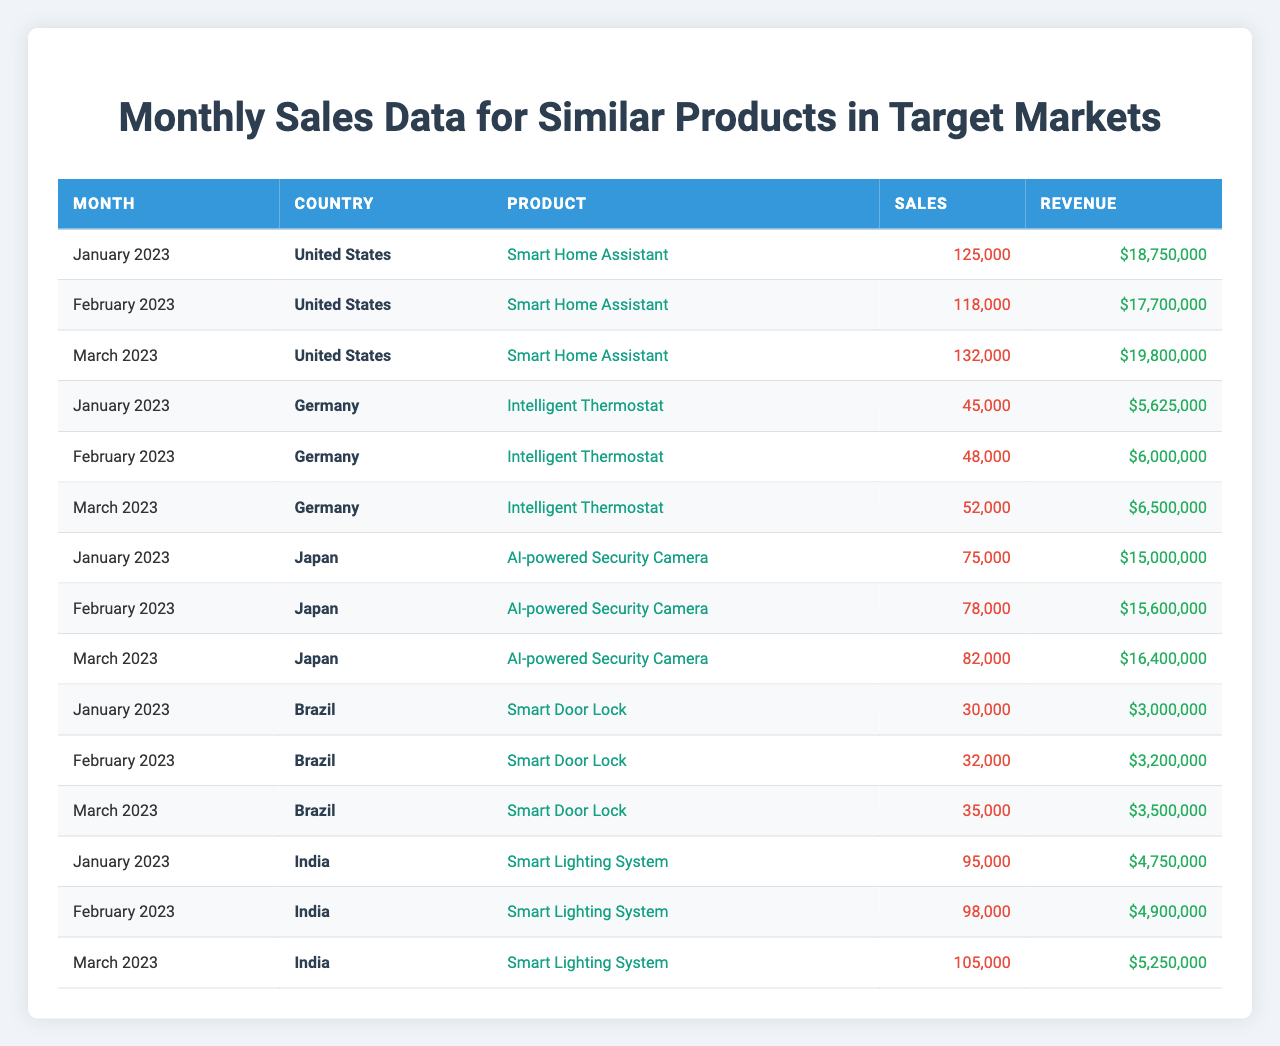What were the total sales for the Smart Home Assistant in the United States in January 2023? The sales figure for the Smart Home Assistant in the United States for January 2023 is listed as 125,000.
Answer: 125,000 Which product had the highest revenue in Japan in February 2023? The table shows that the AI-powered Security Camera had a revenue of $15,600,000 in February 2023, which is higher than any other product listed for Japan.
Answer: AI-powered Security Camera How many sales did the Intelligent Thermostat achieve in Germany in March 2023 compared to February 2023? In March 2023, the Intelligent Thermostat had 52,000 sales while in February 2023, it had 48,000 sales. The difference in sales is 52,000 - 48,000 = 4,000.
Answer: 4,000 What was the total revenue generated by the Smart Lighting System in India during the first quarter of 2023? The revenues for the Smart Lighting System for the first three months are: January $4,750,000, February $4,900,000, and March $5,250,000. Adding these together gives us $4,750,000 + $4,900,000 + $5,250,000 = $14,900,000.
Answer: $14,900,000 Did Brazil's Smart Door Lock experience growth in sales from January to March 2023? The sales figures show that in January it was 30,000, February 32,000, and March 35,000. Since 30,000 < 32,000 < 35,000, we can confirm there was growth.
Answer: Yes What is the average revenue for the Smart Home Assistant in the United States over the first quarter of 2023? The revenues for January, February, and March are $18,750,000, $17,700,000, and $19,800,000 respectively. The total revenue is $18,750,000 + $17,700,000 + $19,800,000 = $56,250,000, and the average is $56,250,000 / 3 = $18,750,000.
Answer: $18,750,000 In which month did India’s Smart Lighting System record the most sales? In India, sales for the Smart Lighting System were 95,000 in January, 98,000 in February, and 105,000 in March. The highest sales figure is 105,000 in March.
Answer: March 2023 What was the percentage increase in sales of the Intelligent Thermostat from February to March 2023 in Germany? The sales for February were 48,000 and for March, 52,000. The increase is 52,000 - 48,000 = 4,000. To find the percentage increase, we do (4,000 / 48,000) * 100 = 8.33%.
Answer: 8.33% Which country had the highest sales volume in January 2023 across all products? The sales figures for January are: United States (125,000), Germany (45,000), Japan (75,000), Brazil (30,000), and India (95,000). The highest sales volume is from the United States at 125,000.
Answer: United States Was there a product that underperformed in sales in Brazil in any of the reported months? The Smart Door Lock consistently showed increasing sales from 30,000 in January to 35,000 in March, indicating it did not underperform in any month.
Answer: No 